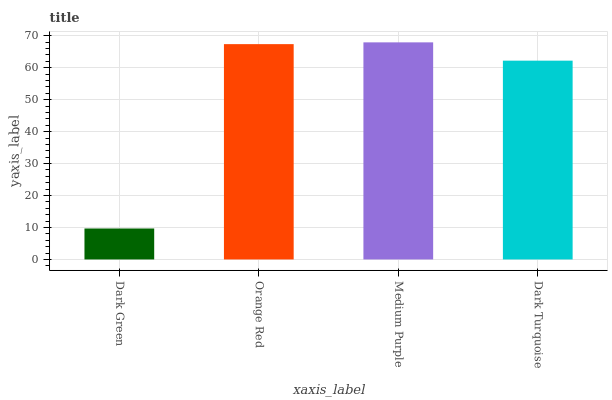Is Dark Green the minimum?
Answer yes or no. Yes. Is Medium Purple the maximum?
Answer yes or no. Yes. Is Orange Red the minimum?
Answer yes or no. No. Is Orange Red the maximum?
Answer yes or no. No. Is Orange Red greater than Dark Green?
Answer yes or no. Yes. Is Dark Green less than Orange Red?
Answer yes or no. Yes. Is Dark Green greater than Orange Red?
Answer yes or no. No. Is Orange Red less than Dark Green?
Answer yes or no. No. Is Orange Red the high median?
Answer yes or no. Yes. Is Dark Turquoise the low median?
Answer yes or no. Yes. Is Medium Purple the high median?
Answer yes or no. No. Is Dark Green the low median?
Answer yes or no. No. 